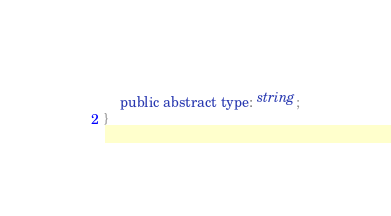<code> <loc_0><loc_0><loc_500><loc_500><_TypeScript_>	public abstract type: string;
}</code> 